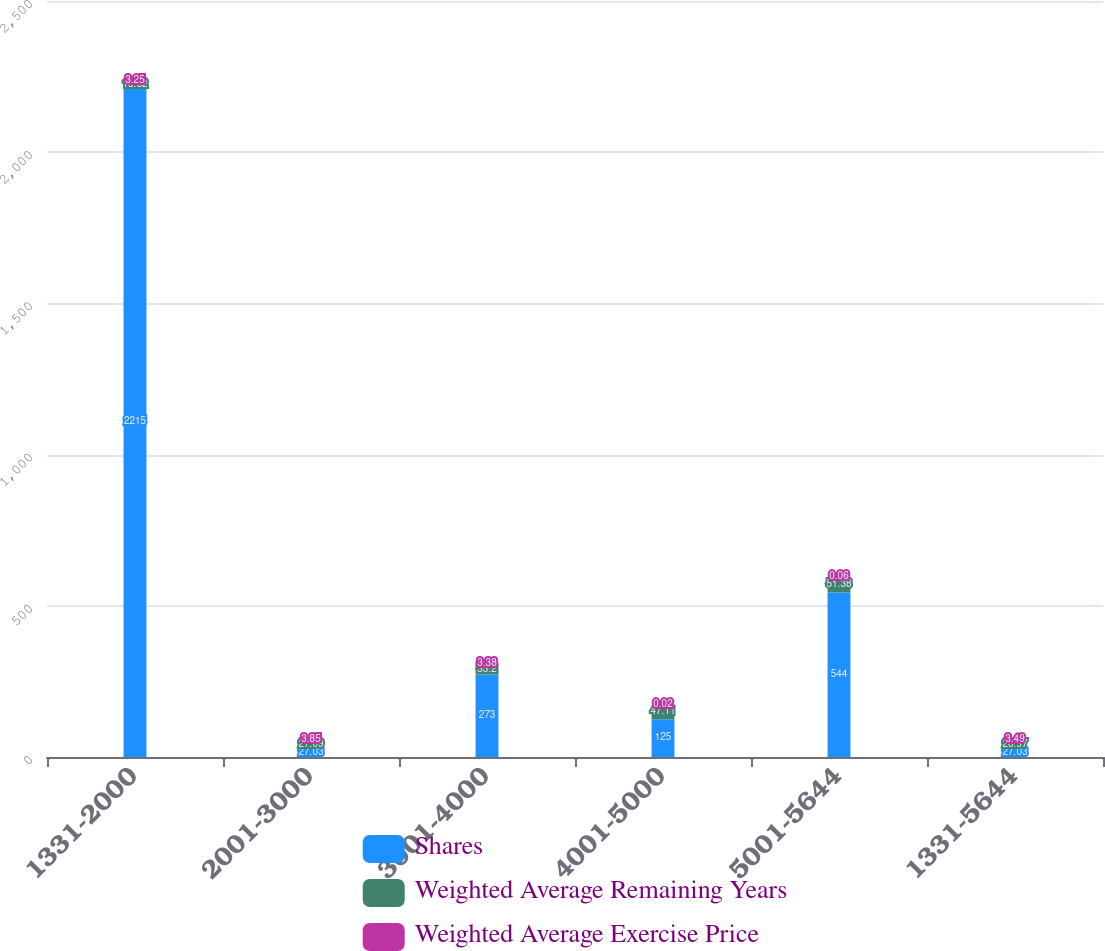<chart> <loc_0><loc_0><loc_500><loc_500><stacked_bar_chart><ecel><fcel>1331-2000<fcel>2001-3000<fcel>3001-4000<fcel>4001-5000<fcel>5001-5644<fcel>1331-5644<nl><fcel>Shares<fcel>2215<fcel>27.03<fcel>273<fcel>125<fcel>544<fcel>27.03<nl><fcel>Weighted Average Remaining Years<fcel>18.62<fcel>27.09<fcel>33.2<fcel>47.11<fcel>51.38<fcel>26.97<nl><fcel>Weighted Average Exercise Price<fcel>3.25<fcel>3.85<fcel>3.38<fcel>0.02<fcel>0.06<fcel>3.49<nl></chart> 